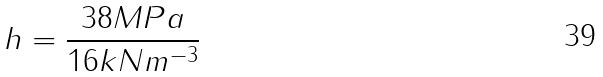Convert formula to latex. <formula><loc_0><loc_0><loc_500><loc_500>h = \frac { 3 8 M P a } { 1 6 k N m ^ { - 3 } }</formula> 